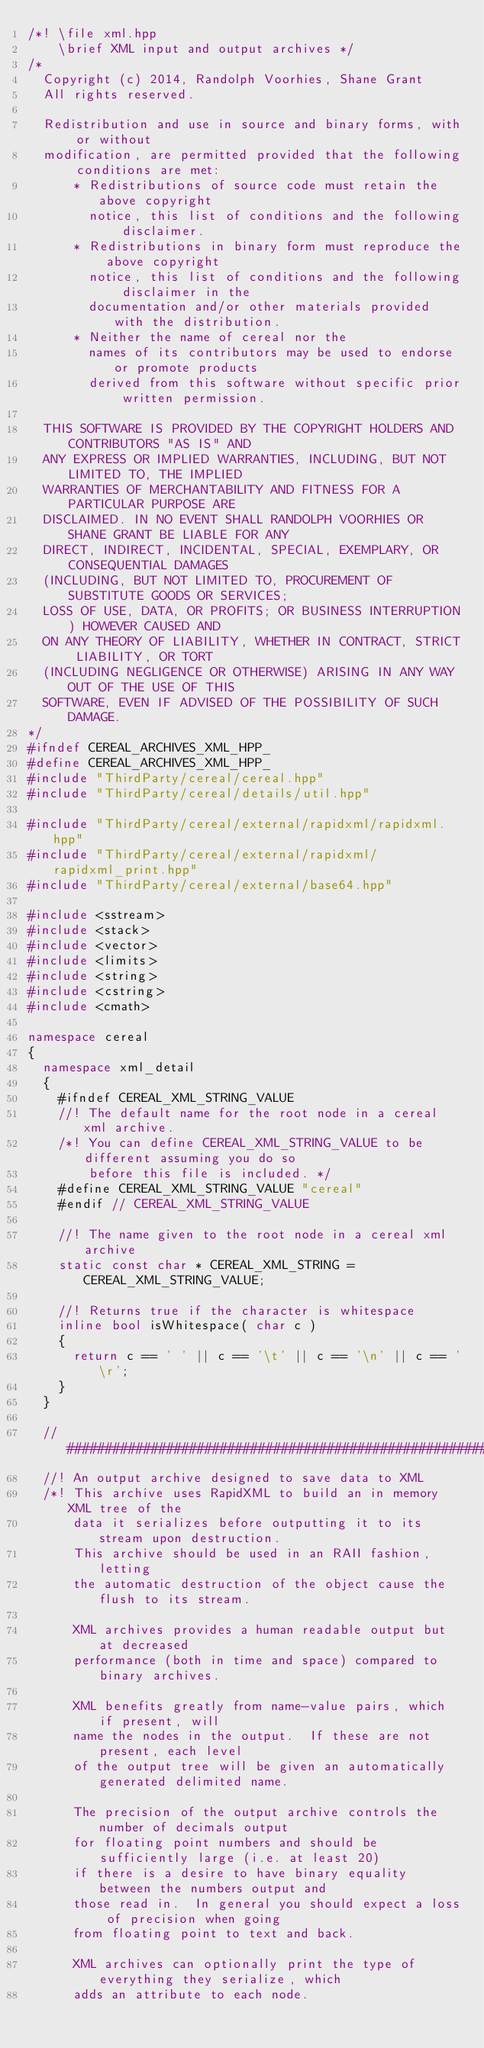<code> <loc_0><loc_0><loc_500><loc_500><_C++_>/*! \file xml.hpp
    \brief XML input and output archives */
/*
  Copyright (c) 2014, Randolph Voorhies, Shane Grant
  All rights reserved.

  Redistribution and use in source and binary forms, with or without
  modification, are permitted provided that the following conditions are met:
      * Redistributions of source code must retain the above copyright
        notice, this list of conditions and the following disclaimer.
      * Redistributions in binary form must reproduce the above copyright
        notice, this list of conditions and the following disclaimer in the
        documentation and/or other materials provided with the distribution.
      * Neither the name of cereal nor the
        names of its contributors may be used to endorse or promote products
        derived from this software without specific prior written permission.

  THIS SOFTWARE IS PROVIDED BY THE COPYRIGHT HOLDERS AND CONTRIBUTORS "AS IS" AND
  ANY EXPRESS OR IMPLIED WARRANTIES, INCLUDING, BUT NOT LIMITED TO, THE IMPLIED
  WARRANTIES OF MERCHANTABILITY AND FITNESS FOR A PARTICULAR PURPOSE ARE
  DISCLAIMED. IN NO EVENT SHALL RANDOLPH VOORHIES OR SHANE GRANT BE LIABLE FOR ANY
  DIRECT, INDIRECT, INCIDENTAL, SPECIAL, EXEMPLARY, OR CONSEQUENTIAL DAMAGES
  (INCLUDING, BUT NOT LIMITED TO, PROCUREMENT OF SUBSTITUTE GOODS OR SERVICES;
  LOSS OF USE, DATA, OR PROFITS; OR BUSINESS INTERRUPTION) HOWEVER CAUSED AND
  ON ANY THEORY OF LIABILITY, WHETHER IN CONTRACT, STRICT LIABILITY, OR TORT
  (INCLUDING NEGLIGENCE OR OTHERWISE) ARISING IN ANY WAY OUT OF THE USE OF THIS
  SOFTWARE, EVEN IF ADVISED OF THE POSSIBILITY OF SUCH DAMAGE.
*/
#ifndef CEREAL_ARCHIVES_XML_HPP_
#define CEREAL_ARCHIVES_XML_HPP_
#include "ThirdParty/cereal/cereal.hpp"
#include "ThirdParty/cereal/details/util.hpp"

#include "ThirdParty/cereal/external/rapidxml/rapidxml.hpp"
#include "ThirdParty/cereal/external/rapidxml/rapidxml_print.hpp"
#include "ThirdParty/cereal/external/base64.hpp"

#include <sstream>
#include <stack>
#include <vector>
#include <limits>
#include <string>
#include <cstring>
#include <cmath>

namespace cereal
{
  namespace xml_detail
  {
    #ifndef CEREAL_XML_STRING_VALUE
    //! The default name for the root node in a cereal xml archive.
    /*! You can define CEREAL_XML_STRING_VALUE to be different assuming you do so
        before this file is included. */
    #define CEREAL_XML_STRING_VALUE "cereal"
    #endif // CEREAL_XML_STRING_VALUE

    //! The name given to the root node in a cereal xml archive
    static const char * CEREAL_XML_STRING = CEREAL_XML_STRING_VALUE;

    //! Returns true if the character is whitespace
    inline bool isWhitespace( char c )
    {
      return c == ' ' || c == '\t' || c == '\n' || c == '\r';
    }
  }

  // ######################################################################
  //! An output archive designed to save data to XML
  /*! This archive uses RapidXML to build an in memory XML tree of the
      data it serializes before outputting it to its stream upon destruction.
      This archive should be used in an RAII fashion, letting
      the automatic destruction of the object cause the flush to its stream.

      XML archives provides a human readable output but at decreased
      performance (both in time and space) compared to binary archives.

      XML benefits greatly from name-value pairs, which if present, will
      name the nodes in the output.  If these are not present, each level
      of the output tree will be given an automatically generated delimited name.

      The precision of the output archive controls the number of decimals output
      for floating point numbers and should be sufficiently large (i.e. at least 20)
      if there is a desire to have binary equality between the numbers output and
      those read in.  In general you should expect a loss of precision when going
      from floating point to text and back.

      XML archives can optionally print the type of everything they serialize, which
      adds an attribute to each node.
</code> 